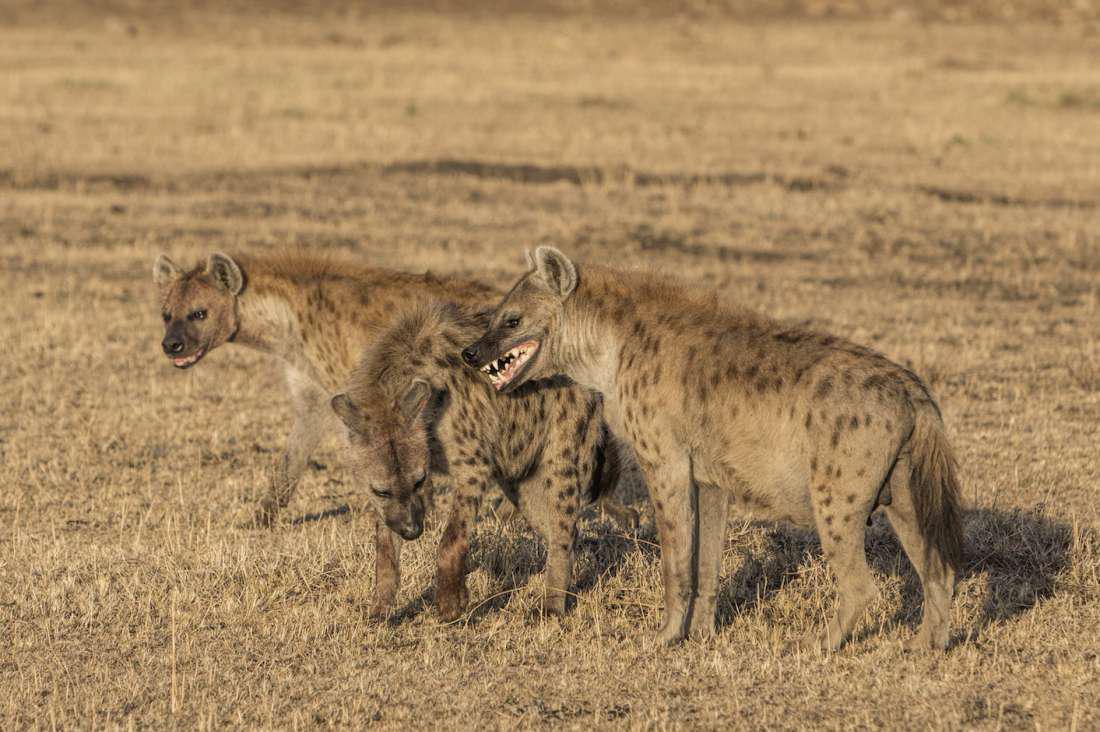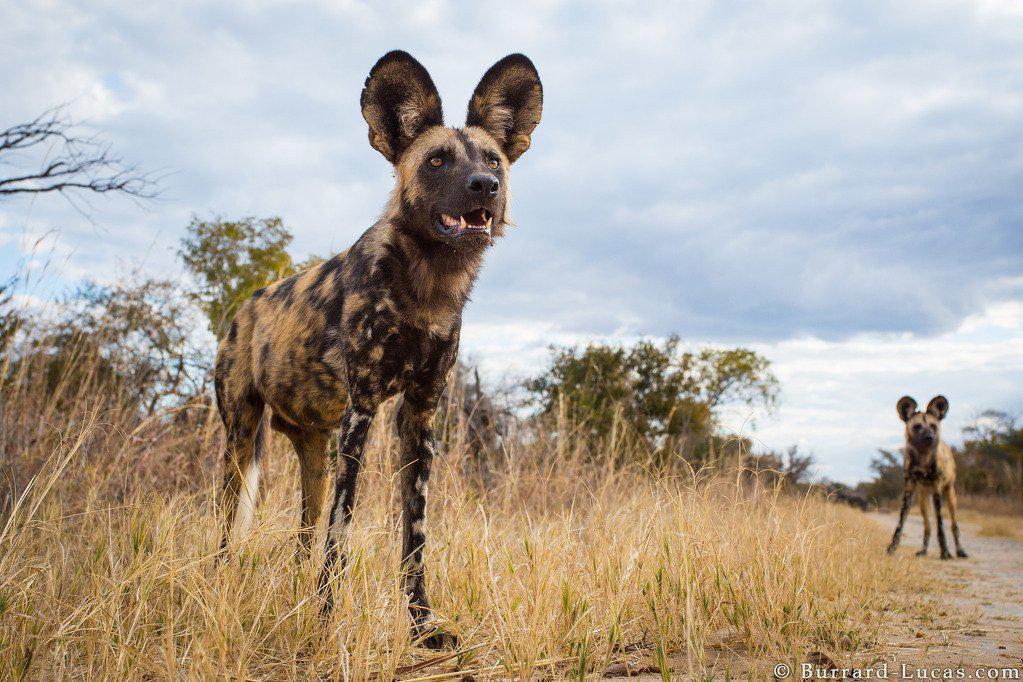The first image is the image on the left, the second image is the image on the right. For the images displayed, is the sentence "there is a hyena on brown grass with its mmouth open exposing the top and bottom teeth from the side view" factually correct? Answer yes or no. Yes. The first image is the image on the left, the second image is the image on the right. Given the left and right images, does the statement "One image shows exactly three hyenas standing with bodies turned leftward, some with heads craning to touch one of the others." hold true? Answer yes or no. Yes. 